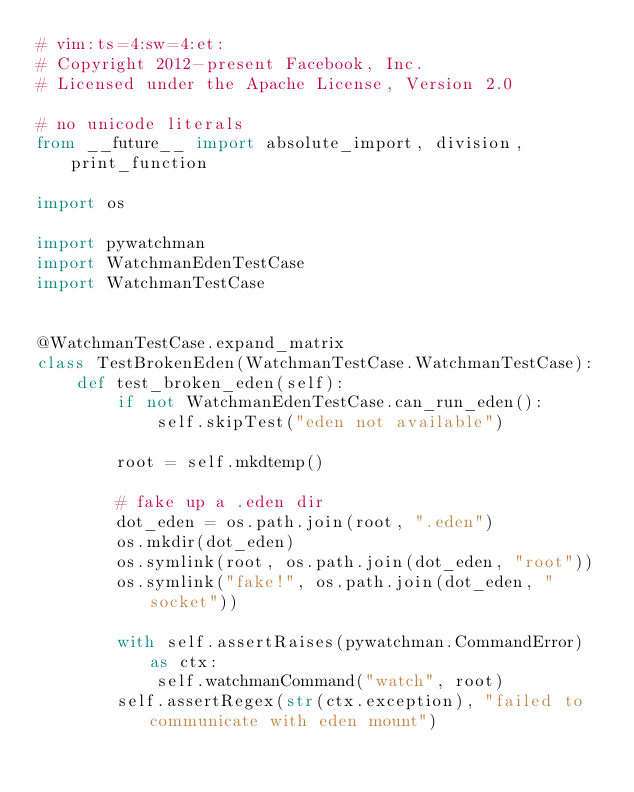Convert code to text. <code><loc_0><loc_0><loc_500><loc_500><_Python_># vim:ts=4:sw=4:et:
# Copyright 2012-present Facebook, Inc.
# Licensed under the Apache License, Version 2.0

# no unicode literals
from __future__ import absolute_import, division, print_function

import os

import pywatchman
import WatchmanEdenTestCase
import WatchmanTestCase


@WatchmanTestCase.expand_matrix
class TestBrokenEden(WatchmanTestCase.WatchmanTestCase):
    def test_broken_eden(self):
        if not WatchmanEdenTestCase.can_run_eden():
            self.skipTest("eden not available")

        root = self.mkdtemp()

        # fake up a .eden dir
        dot_eden = os.path.join(root, ".eden")
        os.mkdir(dot_eden)
        os.symlink(root, os.path.join(dot_eden, "root"))
        os.symlink("fake!", os.path.join(dot_eden, "socket"))

        with self.assertRaises(pywatchman.CommandError) as ctx:
            self.watchmanCommand("watch", root)
        self.assertRegex(str(ctx.exception), "failed to communicate with eden mount")
</code> 